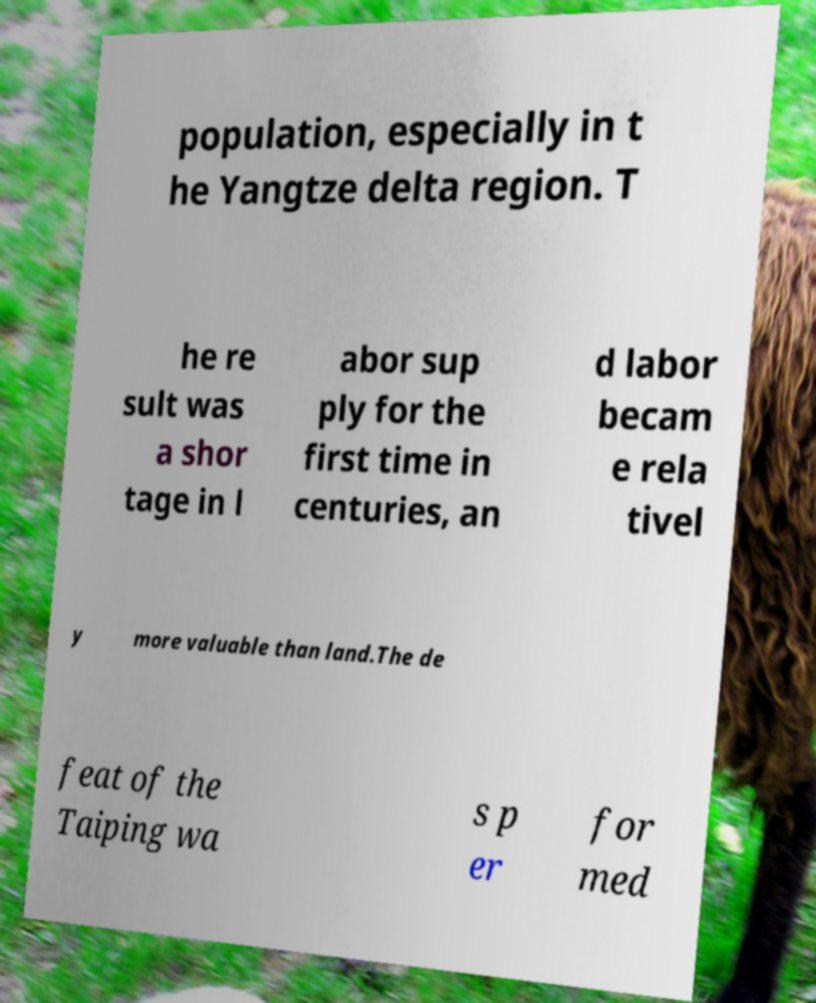For documentation purposes, I need the text within this image transcribed. Could you provide that? population, especially in t he Yangtze delta region. T he re sult was a shor tage in l abor sup ply for the first time in centuries, an d labor becam e rela tivel y more valuable than land.The de feat of the Taiping wa s p er for med 